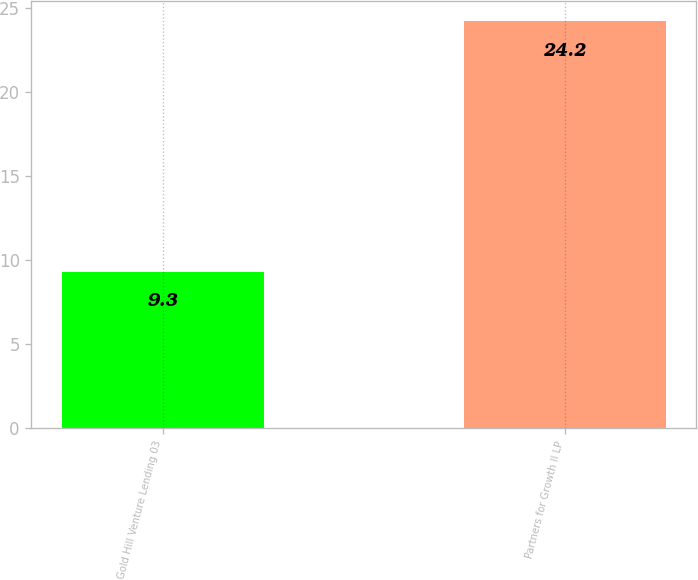<chart> <loc_0><loc_0><loc_500><loc_500><bar_chart><fcel>Gold Hill Venture Lending 03<fcel>Partners for Growth II LP<nl><fcel>9.3<fcel>24.2<nl></chart> 